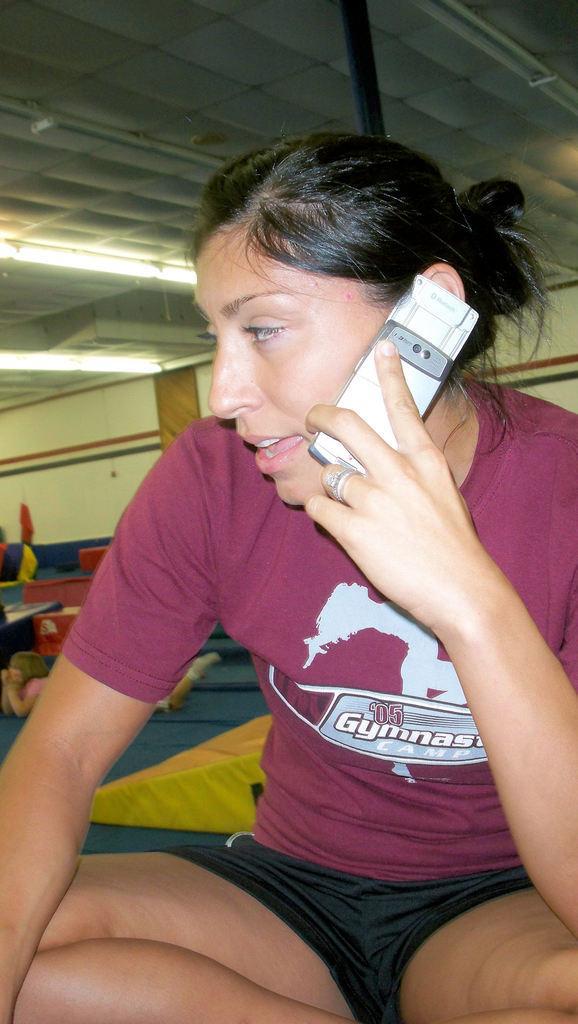Please provide a concise description of this image. In this image there is a woman who is holding the mobile phone and talking. At the top there is ceiling with the lights. In the background there is a wall. At the bottom there is a girl who is sleeping on the floor. 